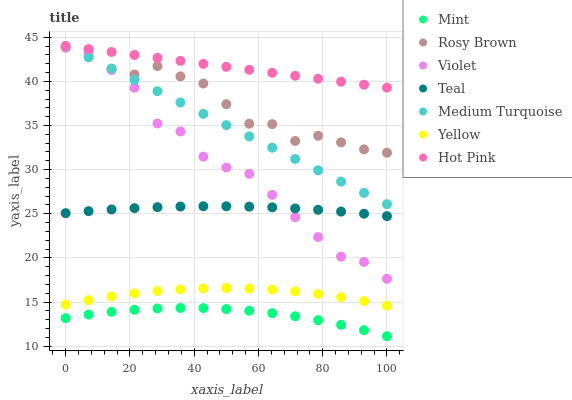Does Mint have the minimum area under the curve?
Answer yes or no. Yes. Does Hot Pink have the maximum area under the curve?
Answer yes or no. Yes. Does Teal have the minimum area under the curve?
Answer yes or no. No. Does Teal have the maximum area under the curve?
Answer yes or no. No. Is Hot Pink the smoothest?
Answer yes or no. Yes. Is Rosy Brown the roughest?
Answer yes or no. Yes. Is Teal the smoothest?
Answer yes or no. No. Is Teal the roughest?
Answer yes or no. No. Does Mint have the lowest value?
Answer yes or no. Yes. Does Teal have the lowest value?
Answer yes or no. No. Does Medium Turquoise have the highest value?
Answer yes or no. Yes. Does Teal have the highest value?
Answer yes or no. No. Is Teal less than Hot Pink?
Answer yes or no. Yes. Is Rosy Brown greater than Mint?
Answer yes or no. Yes. Does Medium Turquoise intersect Rosy Brown?
Answer yes or no. Yes. Is Medium Turquoise less than Rosy Brown?
Answer yes or no. No. Is Medium Turquoise greater than Rosy Brown?
Answer yes or no. No. Does Teal intersect Hot Pink?
Answer yes or no. No. 